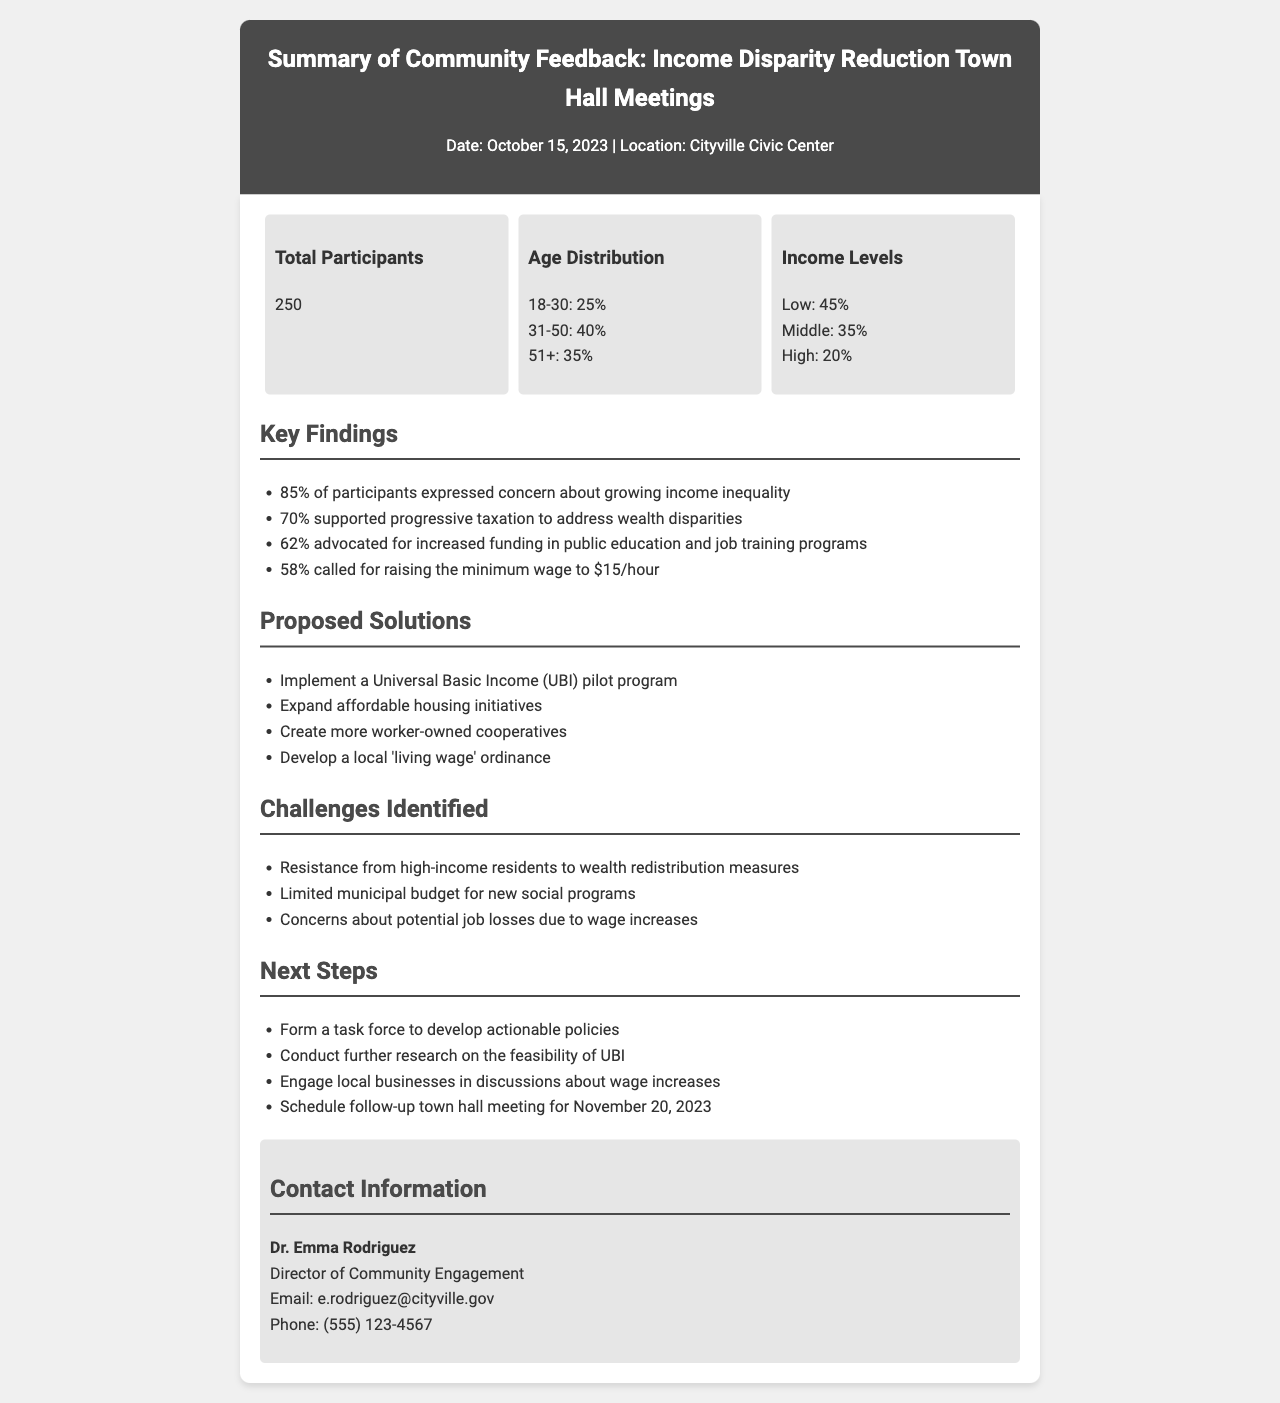What is the total number of participants? The total number of participants is mentioned in the demographic data section as 250.
Answer: 250 What percentage of participants expressed concern about growing income inequality? The document states that 85% of participants expressed concern, which is highlighted in the key findings section.
Answer: 85% What is the proposed minimum wage increase mentioned? The proposed minimum wage increase to $15/hour is detailed in the proposed solutions section.
Answer: $15/hour What percentage of participants supported progressive taxation? The document indicates that 70% supported progressive taxation to address wealth disparities in the key findings.
Answer: 70% What challenge related to wealth redistribution is mentioned? The document lists resistance from high-income residents as a challenge in the challenges identified section.
Answer: Resistance from high-income residents What is one of the next steps proposed for future action? The next steps include forming a task force to develop actionable policies, which is specified in the next steps section.
Answer: Form a task force What date is the follow-up town hall meeting scheduled for? The follow-up town hall meeting is scheduled for November 20, 2023, as mentioned in the next steps.
Answer: November 20, 2023 Who is the Director of Community Engagement? The document provides the name of the Director of Community Engagement as Dr. Emma Rodriguez, located in the contact information section.
Answer: Dr. Emma Rodriguez 